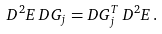Convert formula to latex. <formula><loc_0><loc_0><loc_500><loc_500>D ^ { 2 } E \, D G _ { j } = D G _ { j } ^ { T } \, D ^ { 2 } E \, .</formula> 